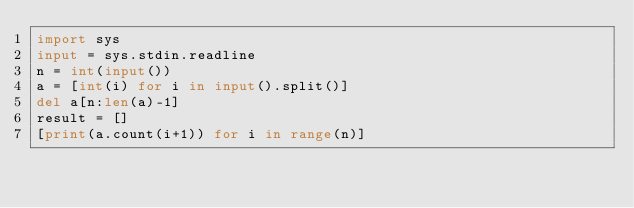Convert code to text. <code><loc_0><loc_0><loc_500><loc_500><_Python_>import sys
input = sys.stdin.readline
n = int(input())
a = [int(i) for i in input().split()]
del a[n:len(a)-1]
result = []
[print(a.count(i+1)) for i in range(n)]
</code> 